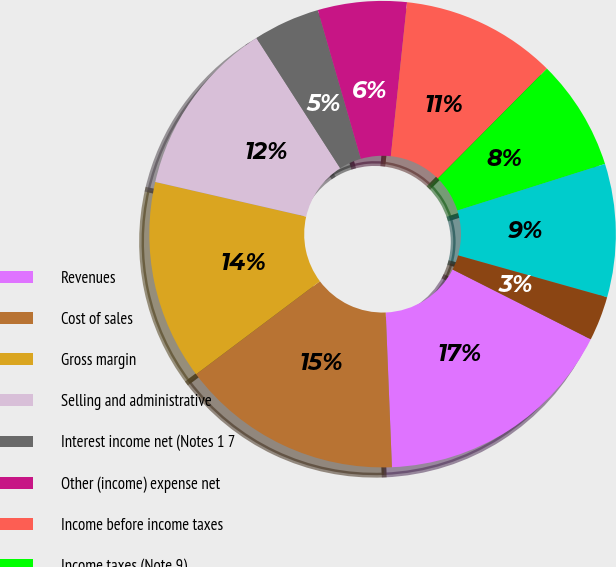<chart> <loc_0><loc_0><loc_500><loc_500><pie_chart><fcel>Revenues<fcel>Cost of sales<fcel>Gross margin<fcel>Selling and administrative<fcel>Interest income net (Notes 1 7<fcel>Other (income) expense net<fcel>Income before income taxes<fcel>Income taxes (Note 9)<fcel>Net income<fcel>Basic earnings per common<nl><fcel>16.92%<fcel>15.38%<fcel>13.85%<fcel>12.31%<fcel>4.62%<fcel>6.15%<fcel>10.77%<fcel>7.69%<fcel>9.23%<fcel>3.08%<nl></chart> 